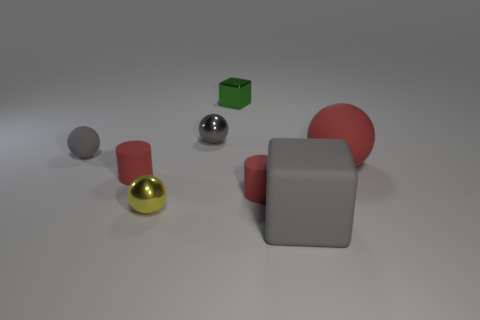Subtract all green cubes. Subtract all purple cylinders. How many cubes are left? 1 Add 1 tiny cylinders. How many objects exist? 9 Subtract all cylinders. How many objects are left? 6 Subtract all rubber blocks. Subtract all tiny red cylinders. How many objects are left? 5 Add 5 green metal things. How many green metal things are left? 6 Add 6 big cyan balls. How many big cyan balls exist? 6 Subtract 0 yellow cubes. How many objects are left? 8 